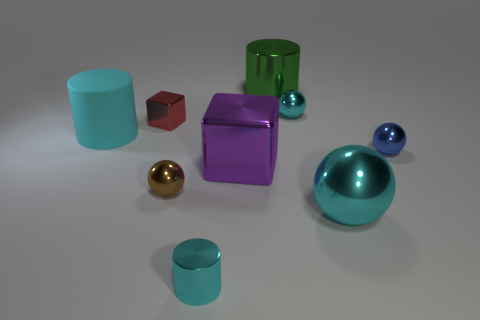Subtract all metallic cylinders. How many cylinders are left? 1 Subtract all blue spheres. How many spheres are left? 3 Subtract all balls. How many objects are left? 5 Add 1 big cyan metallic objects. How many objects exist? 10 Subtract 3 cylinders. How many cylinders are left? 0 Subtract all small blue balls. Subtract all tiny metallic things. How many objects are left? 3 Add 1 small objects. How many small objects are left? 6 Add 5 big cyan things. How many big cyan things exist? 7 Subtract 0 gray blocks. How many objects are left? 9 Subtract all cyan blocks. Subtract all blue balls. How many blocks are left? 2 